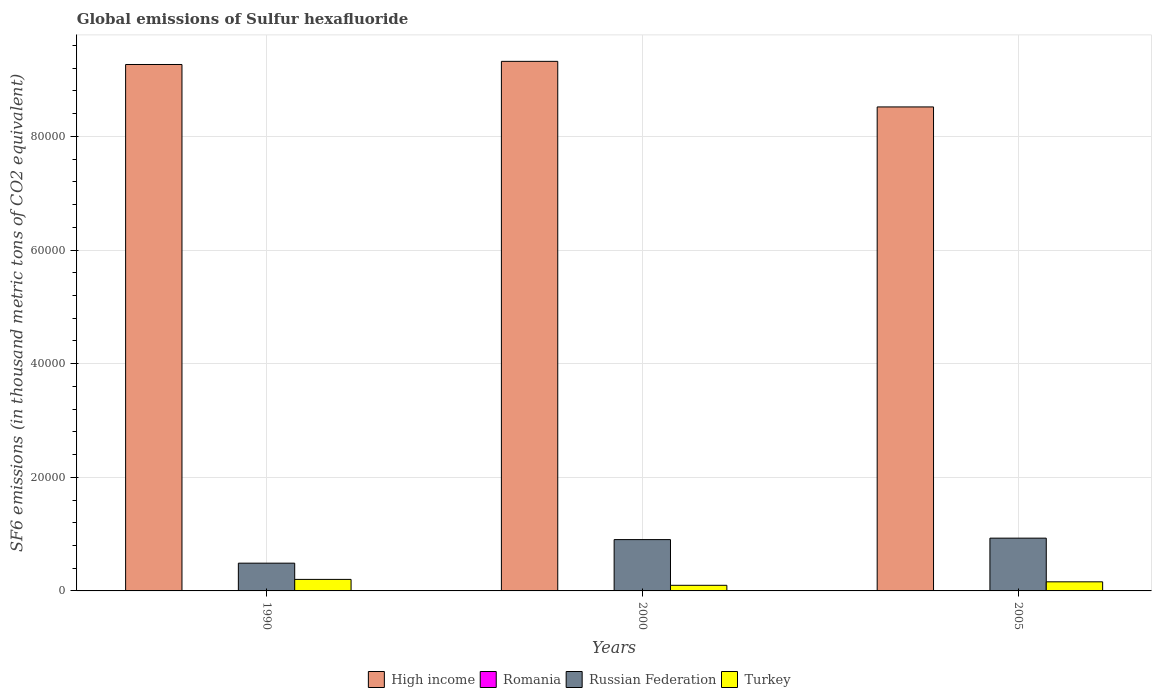How many different coloured bars are there?
Offer a very short reply. 4. How many groups of bars are there?
Make the answer very short. 3. Are the number of bars on each tick of the X-axis equal?
Give a very brief answer. Yes. In how many cases, is the number of bars for a given year not equal to the number of legend labels?
Offer a very short reply. 0. What is the global emissions of Sulfur hexafluoride in Turkey in 2005?
Make the answer very short. 1602.2. Across all years, what is the maximum global emissions of Sulfur hexafluoride in Turkey?
Provide a succinct answer. 2027.1. In which year was the global emissions of Sulfur hexafluoride in Russian Federation maximum?
Provide a succinct answer. 2005. What is the total global emissions of Sulfur hexafluoride in Turkey in the graph?
Make the answer very short. 4618.5. What is the difference between the global emissions of Sulfur hexafluoride in Romania in 1990 and that in 2000?
Keep it short and to the point. -0.4. What is the difference between the global emissions of Sulfur hexafluoride in Romania in 2005 and the global emissions of Sulfur hexafluoride in High income in 1990?
Your answer should be compact. -9.27e+04. What is the average global emissions of Sulfur hexafluoride in Russian Federation per year?
Offer a terse response. 7736.63. In the year 2000, what is the difference between the global emissions of Sulfur hexafluoride in Russian Federation and global emissions of Sulfur hexafluoride in Turkey?
Your answer should be very brief. 8044. What is the ratio of the global emissions of Sulfur hexafluoride in High income in 1990 to that in 2005?
Provide a short and direct response. 1.09. Is the global emissions of Sulfur hexafluoride in High income in 1990 less than that in 2005?
Make the answer very short. No. Is the difference between the global emissions of Sulfur hexafluoride in Russian Federation in 1990 and 2005 greater than the difference between the global emissions of Sulfur hexafluoride in Turkey in 1990 and 2005?
Provide a short and direct response. No. What is the difference between the highest and the second highest global emissions of Sulfur hexafluoride in Turkey?
Offer a very short reply. 424.9. What is the difference between the highest and the lowest global emissions of Sulfur hexafluoride in Russian Federation?
Give a very brief answer. 4403.1. Is the sum of the global emissions of Sulfur hexafluoride in Romania in 1990 and 2000 greater than the maximum global emissions of Sulfur hexafluoride in High income across all years?
Your answer should be compact. No. Is it the case that in every year, the sum of the global emissions of Sulfur hexafluoride in High income and global emissions of Sulfur hexafluoride in Romania is greater than the sum of global emissions of Sulfur hexafluoride in Russian Federation and global emissions of Sulfur hexafluoride in Turkey?
Ensure brevity in your answer.  Yes. What does the 3rd bar from the left in 2005 represents?
Provide a short and direct response. Russian Federation. Is it the case that in every year, the sum of the global emissions of Sulfur hexafluoride in High income and global emissions of Sulfur hexafluoride in Turkey is greater than the global emissions of Sulfur hexafluoride in Romania?
Your answer should be very brief. Yes. What is the difference between two consecutive major ticks on the Y-axis?
Your answer should be compact. 2.00e+04. Does the graph contain grids?
Your answer should be compact. Yes. How many legend labels are there?
Make the answer very short. 4. How are the legend labels stacked?
Give a very brief answer. Horizontal. What is the title of the graph?
Offer a terse response. Global emissions of Sulfur hexafluoride. Does "Sri Lanka" appear as one of the legend labels in the graph?
Your answer should be compact. No. What is the label or title of the Y-axis?
Provide a succinct answer. SF6 emissions (in thousand metric tons of CO2 equivalent). What is the SF6 emissions (in thousand metric tons of CO2 equivalent) in High income in 1990?
Keep it short and to the point. 9.27e+04. What is the SF6 emissions (in thousand metric tons of CO2 equivalent) of Russian Federation in 1990?
Your response must be concise. 4886.8. What is the SF6 emissions (in thousand metric tons of CO2 equivalent) of Turkey in 1990?
Provide a succinct answer. 2027.1. What is the SF6 emissions (in thousand metric tons of CO2 equivalent) of High income in 2000?
Provide a succinct answer. 9.32e+04. What is the SF6 emissions (in thousand metric tons of CO2 equivalent) in Russian Federation in 2000?
Make the answer very short. 9033.2. What is the SF6 emissions (in thousand metric tons of CO2 equivalent) of Turkey in 2000?
Provide a short and direct response. 989.2. What is the SF6 emissions (in thousand metric tons of CO2 equivalent) of High income in 2005?
Provide a succinct answer. 8.52e+04. What is the SF6 emissions (in thousand metric tons of CO2 equivalent) in Romania in 2005?
Your answer should be compact. 2.2. What is the SF6 emissions (in thousand metric tons of CO2 equivalent) in Russian Federation in 2005?
Ensure brevity in your answer.  9289.9. What is the SF6 emissions (in thousand metric tons of CO2 equivalent) in Turkey in 2005?
Keep it short and to the point. 1602.2. Across all years, what is the maximum SF6 emissions (in thousand metric tons of CO2 equivalent) in High income?
Give a very brief answer. 9.32e+04. Across all years, what is the maximum SF6 emissions (in thousand metric tons of CO2 equivalent) of Romania?
Ensure brevity in your answer.  2.2. Across all years, what is the maximum SF6 emissions (in thousand metric tons of CO2 equivalent) in Russian Federation?
Your answer should be compact. 9289.9. Across all years, what is the maximum SF6 emissions (in thousand metric tons of CO2 equivalent) of Turkey?
Your answer should be compact. 2027.1. Across all years, what is the minimum SF6 emissions (in thousand metric tons of CO2 equivalent) in High income?
Your answer should be compact. 8.52e+04. Across all years, what is the minimum SF6 emissions (in thousand metric tons of CO2 equivalent) of Romania?
Offer a terse response. 1.6. Across all years, what is the minimum SF6 emissions (in thousand metric tons of CO2 equivalent) of Russian Federation?
Your answer should be compact. 4886.8. Across all years, what is the minimum SF6 emissions (in thousand metric tons of CO2 equivalent) of Turkey?
Make the answer very short. 989.2. What is the total SF6 emissions (in thousand metric tons of CO2 equivalent) in High income in the graph?
Your response must be concise. 2.71e+05. What is the total SF6 emissions (in thousand metric tons of CO2 equivalent) in Romania in the graph?
Keep it short and to the point. 5.8. What is the total SF6 emissions (in thousand metric tons of CO2 equivalent) of Russian Federation in the graph?
Give a very brief answer. 2.32e+04. What is the total SF6 emissions (in thousand metric tons of CO2 equivalent) in Turkey in the graph?
Give a very brief answer. 4618.5. What is the difference between the SF6 emissions (in thousand metric tons of CO2 equivalent) of High income in 1990 and that in 2000?
Your response must be concise. -551.2. What is the difference between the SF6 emissions (in thousand metric tons of CO2 equivalent) of Romania in 1990 and that in 2000?
Offer a terse response. -0.4. What is the difference between the SF6 emissions (in thousand metric tons of CO2 equivalent) in Russian Federation in 1990 and that in 2000?
Offer a terse response. -4146.4. What is the difference between the SF6 emissions (in thousand metric tons of CO2 equivalent) in Turkey in 1990 and that in 2000?
Provide a succinct answer. 1037.9. What is the difference between the SF6 emissions (in thousand metric tons of CO2 equivalent) in High income in 1990 and that in 2005?
Your answer should be compact. 7470.39. What is the difference between the SF6 emissions (in thousand metric tons of CO2 equivalent) of Russian Federation in 1990 and that in 2005?
Your response must be concise. -4403.1. What is the difference between the SF6 emissions (in thousand metric tons of CO2 equivalent) in Turkey in 1990 and that in 2005?
Keep it short and to the point. 424.9. What is the difference between the SF6 emissions (in thousand metric tons of CO2 equivalent) in High income in 2000 and that in 2005?
Keep it short and to the point. 8021.59. What is the difference between the SF6 emissions (in thousand metric tons of CO2 equivalent) of Russian Federation in 2000 and that in 2005?
Keep it short and to the point. -256.7. What is the difference between the SF6 emissions (in thousand metric tons of CO2 equivalent) of Turkey in 2000 and that in 2005?
Give a very brief answer. -613. What is the difference between the SF6 emissions (in thousand metric tons of CO2 equivalent) of High income in 1990 and the SF6 emissions (in thousand metric tons of CO2 equivalent) of Romania in 2000?
Your answer should be compact. 9.27e+04. What is the difference between the SF6 emissions (in thousand metric tons of CO2 equivalent) in High income in 1990 and the SF6 emissions (in thousand metric tons of CO2 equivalent) in Russian Federation in 2000?
Keep it short and to the point. 8.36e+04. What is the difference between the SF6 emissions (in thousand metric tons of CO2 equivalent) of High income in 1990 and the SF6 emissions (in thousand metric tons of CO2 equivalent) of Turkey in 2000?
Offer a terse response. 9.17e+04. What is the difference between the SF6 emissions (in thousand metric tons of CO2 equivalent) in Romania in 1990 and the SF6 emissions (in thousand metric tons of CO2 equivalent) in Russian Federation in 2000?
Your answer should be very brief. -9031.6. What is the difference between the SF6 emissions (in thousand metric tons of CO2 equivalent) in Romania in 1990 and the SF6 emissions (in thousand metric tons of CO2 equivalent) in Turkey in 2000?
Provide a succinct answer. -987.6. What is the difference between the SF6 emissions (in thousand metric tons of CO2 equivalent) of Russian Federation in 1990 and the SF6 emissions (in thousand metric tons of CO2 equivalent) of Turkey in 2000?
Offer a terse response. 3897.6. What is the difference between the SF6 emissions (in thousand metric tons of CO2 equivalent) of High income in 1990 and the SF6 emissions (in thousand metric tons of CO2 equivalent) of Romania in 2005?
Offer a very short reply. 9.27e+04. What is the difference between the SF6 emissions (in thousand metric tons of CO2 equivalent) of High income in 1990 and the SF6 emissions (in thousand metric tons of CO2 equivalent) of Russian Federation in 2005?
Your response must be concise. 8.34e+04. What is the difference between the SF6 emissions (in thousand metric tons of CO2 equivalent) in High income in 1990 and the SF6 emissions (in thousand metric tons of CO2 equivalent) in Turkey in 2005?
Make the answer very short. 9.11e+04. What is the difference between the SF6 emissions (in thousand metric tons of CO2 equivalent) of Romania in 1990 and the SF6 emissions (in thousand metric tons of CO2 equivalent) of Russian Federation in 2005?
Keep it short and to the point. -9288.3. What is the difference between the SF6 emissions (in thousand metric tons of CO2 equivalent) of Romania in 1990 and the SF6 emissions (in thousand metric tons of CO2 equivalent) of Turkey in 2005?
Give a very brief answer. -1600.6. What is the difference between the SF6 emissions (in thousand metric tons of CO2 equivalent) in Russian Federation in 1990 and the SF6 emissions (in thousand metric tons of CO2 equivalent) in Turkey in 2005?
Make the answer very short. 3284.6. What is the difference between the SF6 emissions (in thousand metric tons of CO2 equivalent) of High income in 2000 and the SF6 emissions (in thousand metric tons of CO2 equivalent) of Romania in 2005?
Give a very brief answer. 9.32e+04. What is the difference between the SF6 emissions (in thousand metric tons of CO2 equivalent) of High income in 2000 and the SF6 emissions (in thousand metric tons of CO2 equivalent) of Russian Federation in 2005?
Offer a terse response. 8.39e+04. What is the difference between the SF6 emissions (in thousand metric tons of CO2 equivalent) in High income in 2000 and the SF6 emissions (in thousand metric tons of CO2 equivalent) in Turkey in 2005?
Your answer should be compact. 9.16e+04. What is the difference between the SF6 emissions (in thousand metric tons of CO2 equivalent) in Romania in 2000 and the SF6 emissions (in thousand metric tons of CO2 equivalent) in Russian Federation in 2005?
Your answer should be very brief. -9287.9. What is the difference between the SF6 emissions (in thousand metric tons of CO2 equivalent) in Romania in 2000 and the SF6 emissions (in thousand metric tons of CO2 equivalent) in Turkey in 2005?
Ensure brevity in your answer.  -1600.2. What is the difference between the SF6 emissions (in thousand metric tons of CO2 equivalent) of Russian Federation in 2000 and the SF6 emissions (in thousand metric tons of CO2 equivalent) of Turkey in 2005?
Provide a short and direct response. 7431. What is the average SF6 emissions (in thousand metric tons of CO2 equivalent) of High income per year?
Offer a very short reply. 9.04e+04. What is the average SF6 emissions (in thousand metric tons of CO2 equivalent) of Romania per year?
Provide a succinct answer. 1.93. What is the average SF6 emissions (in thousand metric tons of CO2 equivalent) of Russian Federation per year?
Your answer should be compact. 7736.63. What is the average SF6 emissions (in thousand metric tons of CO2 equivalent) in Turkey per year?
Give a very brief answer. 1539.5. In the year 1990, what is the difference between the SF6 emissions (in thousand metric tons of CO2 equivalent) of High income and SF6 emissions (in thousand metric tons of CO2 equivalent) of Romania?
Ensure brevity in your answer.  9.27e+04. In the year 1990, what is the difference between the SF6 emissions (in thousand metric tons of CO2 equivalent) in High income and SF6 emissions (in thousand metric tons of CO2 equivalent) in Russian Federation?
Your response must be concise. 8.78e+04. In the year 1990, what is the difference between the SF6 emissions (in thousand metric tons of CO2 equivalent) in High income and SF6 emissions (in thousand metric tons of CO2 equivalent) in Turkey?
Offer a terse response. 9.06e+04. In the year 1990, what is the difference between the SF6 emissions (in thousand metric tons of CO2 equivalent) of Romania and SF6 emissions (in thousand metric tons of CO2 equivalent) of Russian Federation?
Provide a succinct answer. -4885.2. In the year 1990, what is the difference between the SF6 emissions (in thousand metric tons of CO2 equivalent) of Romania and SF6 emissions (in thousand metric tons of CO2 equivalent) of Turkey?
Your answer should be very brief. -2025.5. In the year 1990, what is the difference between the SF6 emissions (in thousand metric tons of CO2 equivalent) in Russian Federation and SF6 emissions (in thousand metric tons of CO2 equivalent) in Turkey?
Offer a terse response. 2859.7. In the year 2000, what is the difference between the SF6 emissions (in thousand metric tons of CO2 equivalent) of High income and SF6 emissions (in thousand metric tons of CO2 equivalent) of Romania?
Your response must be concise. 9.32e+04. In the year 2000, what is the difference between the SF6 emissions (in thousand metric tons of CO2 equivalent) of High income and SF6 emissions (in thousand metric tons of CO2 equivalent) of Russian Federation?
Your answer should be very brief. 8.42e+04. In the year 2000, what is the difference between the SF6 emissions (in thousand metric tons of CO2 equivalent) in High income and SF6 emissions (in thousand metric tons of CO2 equivalent) in Turkey?
Provide a succinct answer. 9.22e+04. In the year 2000, what is the difference between the SF6 emissions (in thousand metric tons of CO2 equivalent) of Romania and SF6 emissions (in thousand metric tons of CO2 equivalent) of Russian Federation?
Provide a short and direct response. -9031.2. In the year 2000, what is the difference between the SF6 emissions (in thousand metric tons of CO2 equivalent) in Romania and SF6 emissions (in thousand metric tons of CO2 equivalent) in Turkey?
Your response must be concise. -987.2. In the year 2000, what is the difference between the SF6 emissions (in thousand metric tons of CO2 equivalent) in Russian Federation and SF6 emissions (in thousand metric tons of CO2 equivalent) in Turkey?
Provide a succinct answer. 8044. In the year 2005, what is the difference between the SF6 emissions (in thousand metric tons of CO2 equivalent) in High income and SF6 emissions (in thousand metric tons of CO2 equivalent) in Romania?
Provide a succinct answer. 8.52e+04. In the year 2005, what is the difference between the SF6 emissions (in thousand metric tons of CO2 equivalent) in High income and SF6 emissions (in thousand metric tons of CO2 equivalent) in Russian Federation?
Keep it short and to the point. 7.59e+04. In the year 2005, what is the difference between the SF6 emissions (in thousand metric tons of CO2 equivalent) in High income and SF6 emissions (in thousand metric tons of CO2 equivalent) in Turkey?
Provide a succinct answer. 8.36e+04. In the year 2005, what is the difference between the SF6 emissions (in thousand metric tons of CO2 equivalent) of Romania and SF6 emissions (in thousand metric tons of CO2 equivalent) of Russian Federation?
Offer a very short reply. -9287.7. In the year 2005, what is the difference between the SF6 emissions (in thousand metric tons of CO2 equivalent) of Romania and SF6 emissions (in thousand metric tons of CO2 equivalent) of Turkey?
Offer a very short reply. -1600. In the year 2005, what is the difference between the SF6 emissions (in thousand metric tons of CO2 equivalent) in Russian Federation and SF6 emissions (in thousand metric tons of CO2 equivalent) in Turkey?
Make the answer very short. 7687.7. What is the ratio of the SF6 emissions (in thousand metric tons of CO2 equivalent) in High income in 1990 to that in 2000?
Keep it short and to the point. 0.99. What is the ratio of the SF6 emissions (in thousand metric tons of CO2 equivalent) of Romania in 1990 to that in 2000?
Your response must be concise. 0.8. What is the ratio of the SF6 emissions (in thousand metric tons of CO2 equivalent) in Russian Federation in 1990 to that in 2000?
Keep it short and to the point. 0.54. What is the ratio of the SF6 emissions (in thousand metric tons of CO2 equivalent) of Turkey in 1990 to that in 2000?
Your answer should be very brief. 2.05. What is the ratio of the SF6 emissions (in thousand metric tons of CO2 equivalent) of High income in 1990 to that in 2005?
Offer a terse response. 1.09. What is the ratio of the SF6 emissions (in thousand metric tons of CO2 equivalent) in Romania in 1990 to that in 2005?
Offer a terse response. 0.73. What is the ratio of the SF6 emissions (in thousand metric tons of CO2 equivalent) in Russian Federation in 1990 to that in 2005?
Offer a very short reply. 0.53. What is the ratio of the SF6 emissions (in thousand metric tons of CO2 equivalent) in Turkey in 1990 to that in 2005?
Your answer should be very brief. 1.27. What is the ratio of the SF6 emissions (in thousand metric tons of CO2 equivalent) of High income in 2000 to that in 2005?
Your response must be concise. 1.09. What is the ratio of the SF6 emissions (in thousand metric tons of CO2 equivalent) in Romania in 2000 to that in 2005?
Ensure brevity in your answer.  0.91. What is the ratio of the SF6 emissions (in thousand metric tons of CO2 equivalent) in Russian Federation in 2000 to that in 2005?
Your answer should be compact. 0.97. What is the ratio of the SF6 emissions (in thousand metric tons of CO2 equivalent) of Turkey in 2000 to that in 2005?
Offer a terse response. 0.62. What is the difference between the highest and the second highest SF6 emissions (in thousand metric tons of CO2 equivalent) of High income?
Offer a very short reply. 551.2. What is the difference between the highest and the second highest SF6 emissions (in thousand metric tons of CO2 equivalent) of Russian Federation?
Your answer should be compact. 256.7. What is the difference between the highest and the second highest SF6 emissions (in thousand metric tons of CO2 equivalent) of Turkey?
Your answer should be compact. 424.9. What is the difference between the highest and the lowest SF6 emissions (in thousand metric tons of CO2 equivalent) of High income?
Ensure brevity in your answer.  8021.59. What is the difference between the highest and the lowest SF6 emissions (in thousand metric tons of CO2 equivalent) in Romania?
Provide a succinct answer. 0.6. What is the difference between the highest and the lowest SF6 emissions (in thousand metric tons of CO2 equivalent) in Russian Federation?
Offer a very short reply. 4403.1. What is the difference between the highest and the lowest SF6 emissions (in thousand metric tons of CO2 equivalent) of Turkey?
Offer a very short reply. 1037.9. 